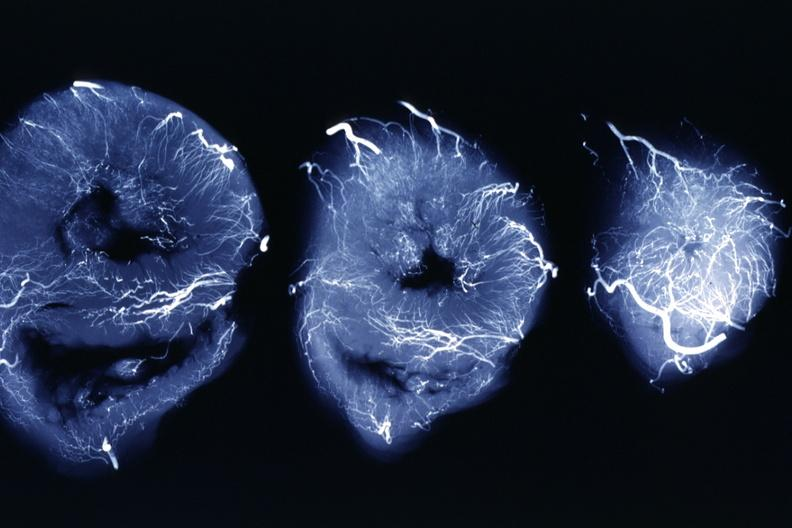where is this from?
Answer the question using a single word or phrase. Heart 